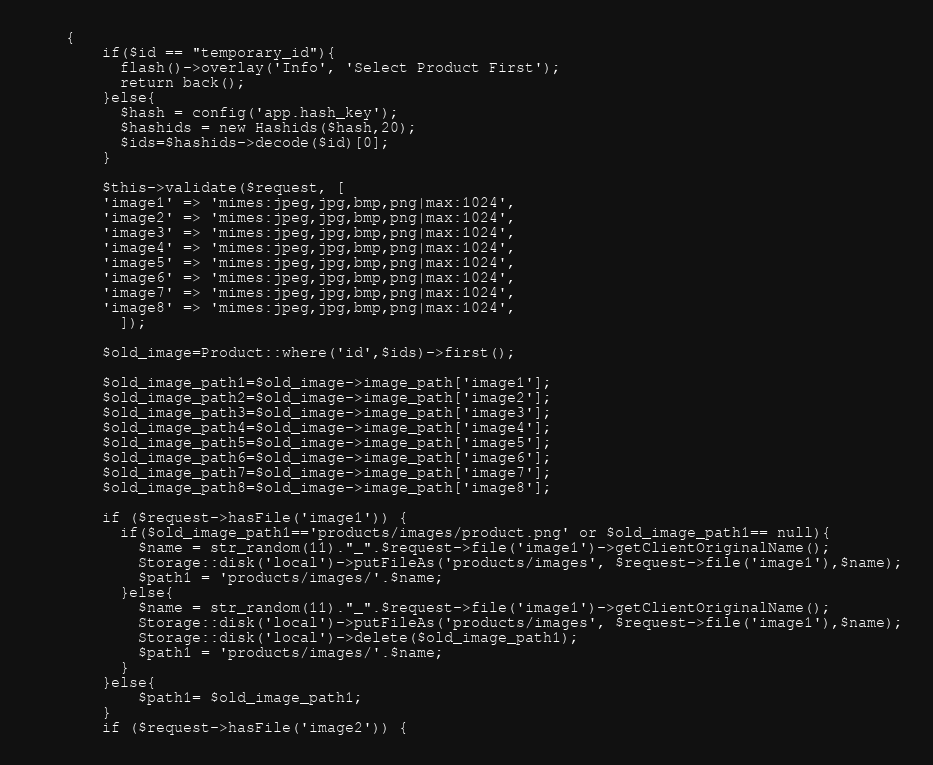Convert code to text. <code><loc_0><loc_0><loc_500><loc_500><_PHP_>    {
        if($id == "temporary_id"){
          flash()->overlay('Info', 'Select Product First');
          return back();
        }else{
          $hash = config('app.hash_key');
          $hashids = new Hashids($hash,20);
          $ids=$hashids->decode($id)[0];
        }

        $this->validate($request, [
        'image1' => 'mimes:jpeg,jpg,bmp,png|max:1024',
        'image2' => 'mimes:jpeg,jpg,bmp,png|max:1024',
        'image3' => 'mimes:jpeg,jpg,bmp,png|max:1024',
        'image4' => 'mimes:jpeg,jpg,bmp,png|max:1024',
        'image5' => 'mimes:jpeg,jpg,bmp,png|max:1024',
        'image6' => 'mimes:jpeg,jpg,bmp,png|max:1024',
        'image7' => 'mimes:jpeg,jpg,bmp,png|max:1024',
        'image8' => 'mimes:jpeg,jpg,bmp,png|max:1024',
          ]);

        $old_image=Product::where('id',$ids)->first();

        $old_image_path1=$old_image->image_path['image1'];
        $old_image_path2=$old_image->image_path['image2'];
        $old_image_path3=$old_image->image_path['image3'];
        $old_image_path4=$old_image->image_path['image4'];
        $old_image_path5=$old_image->image_path['image5'];
        $old_image_path6=$old_image->image_path['image6'];
        $old_image_path7=$old_image->image_path['image7'];
        $old_image_path8=$old_image->image_path['image8'];

        if ($request->hasFile('image1')) {
          if($old_image_path1=='products/images/product.png' or $old_image_path1== null){
            $name = str_random(11)."_".$request->file('image1')->getClientOriginalName();
            Storage::disk('local')->putFileAs('products/images', $request->file('image1'),$name);
            $path1 = 'products/images/'.$name;
          }else{
            $name = str_random(11)."_".$request->file('image1')->getClientOriginalName();
            Storage::disk('local')->putFileAs('products/images', $request->file('image1'),$name);
            Storage::disk('local')->delete($old_image_path1);
            $path1 = 'products/images/'.$name;
          }
        }else{
            $path1= $old_image_path1;
        }
        if ($request->hasFile('image2')) {</code> 